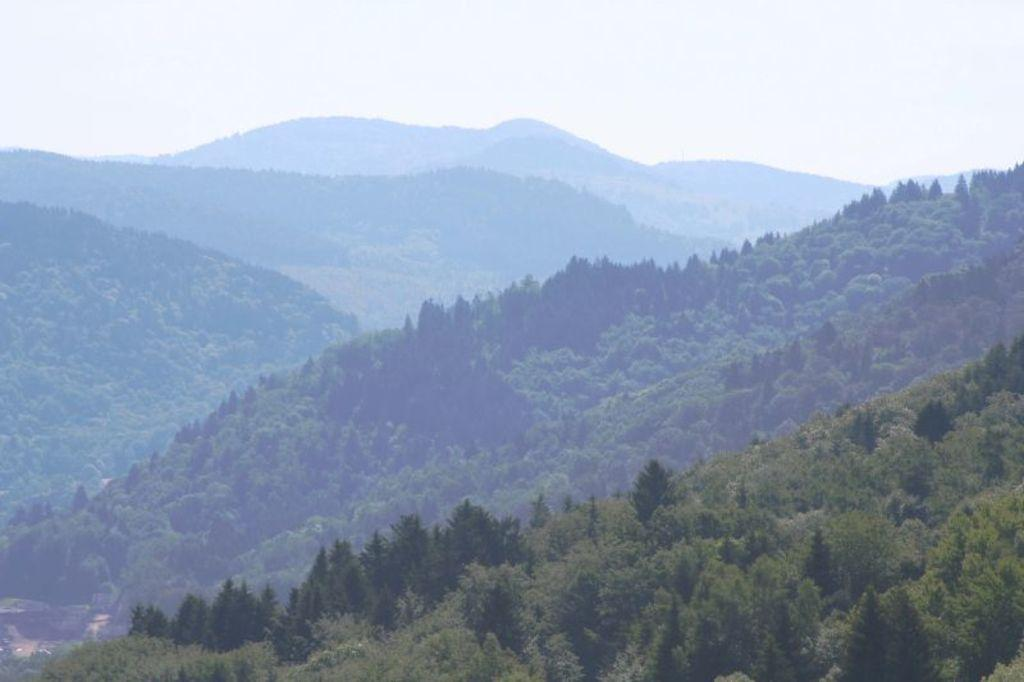What type of vegetation can be seen in the image? There are trees in the image. What geographical features are present in the image? There are hills in the image. What is visible in the background of the image? The sky is visible in the background of the image. What is the average income of the trees in the image? There is no income associated with the trees in the image, as they are natural vegetation and not capable of earning money. 